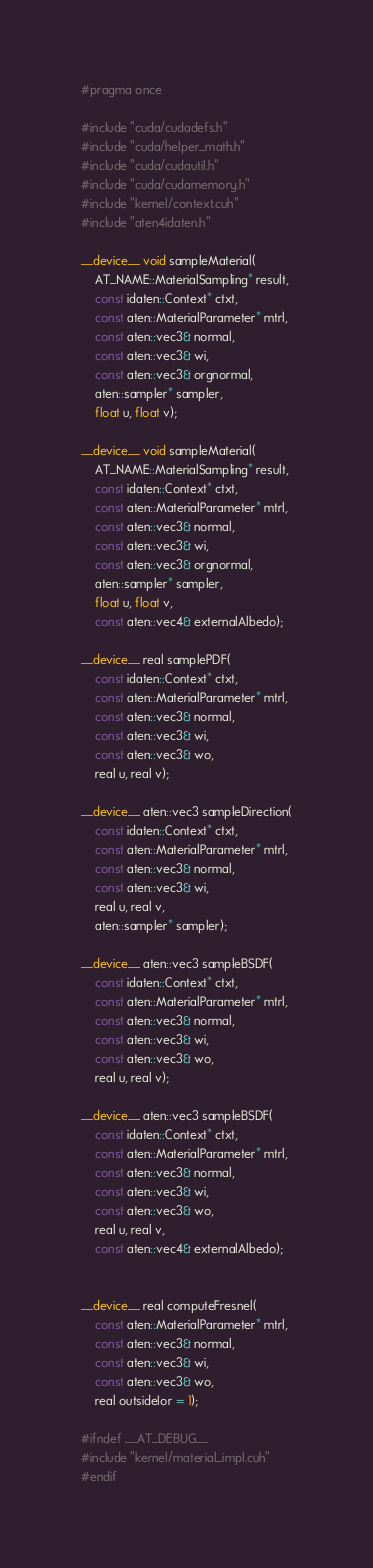Convert code to text. <code><loc_0><loc_0><loc_500><loc_500><_Cuda_>#pragma once

#include "cuda/cudadefs.h"
#include "cuda/helper_math.h"
#include "cuda/cudautil.h"
#include "cuda/cudamemory.h"
#include "kernel/context.cuh"
#include "aten4idaten.h"

__device__ void sampleMaterial(
    AT_NAME::MaterialSampling* result,
    const idaten::Context* ctxt,
    const aten::MaterialParameter* mtrl,
    const aten::vec3& normal,
    const aten::vec3& wi,
    const aten::vec3& orgnormal,
    aten::sampler* sampler,
    float u, float v);

__device__ void sampleMaterial(
    AT_NAME::MaterialSampling* result,
    const idaten::Context* ctxt,
    const aten::MaterialParameter* mtrl,
    const aten::vec3& normal,
    const aten::vec3& wi,
    const aten::vec3& orgnormal,
    aten::sampler* sampler,
    float u, float v,
    const aten::vec4& externalAlbedo);

__device__ real samplePDF(
    const idaten::Context* ctxt,
    const aten::MaterialParameter* mtrl,
    const aten::vec3& normal,
    const aten::vec3& wi,
    const aten::vec3& wo,
    real u, real v);

__device__ aten::vec3 sampleDirection(
    const idaten::Context* ctxt,
    const aten::MaterialParameter* mtrl,
    const aten::vec3& normal,
    const aten::vec3& wi,
    real u, real v,
    aten::sampler* sampler);

__device__ aten::vec3 sampleBSDF(
    const idaten::Context* ctxt,
    const aten::MaterialParameter* mtrl,
    const aten::vec3& normal,
    const aten::vec3& wi,
    const aten::vec3& wo,
    real u, real v);

__device__ aten::vec3 sampleBSDF(
    const idaten::Context* ctxt,
    const aten::MaterialParameter* mtrl,
    const aten::vec3& normal,
    const aten::vec3& wi,
    const aten::vec3& wo,
    real u, real v,
    const aten::vec4& externalAlbedo);


__device__ real computeFresnel(
    const aten::MaterialParameter* mtrl,
    const aten::vec3& normal,
    const aten::vec3& wi,
    const aten::vec3& wo,
    real outsideIor = 1);

#ifndef __AT_DEBUG__
#include "kernel/material_impl.cuh"
#endif
</code> 